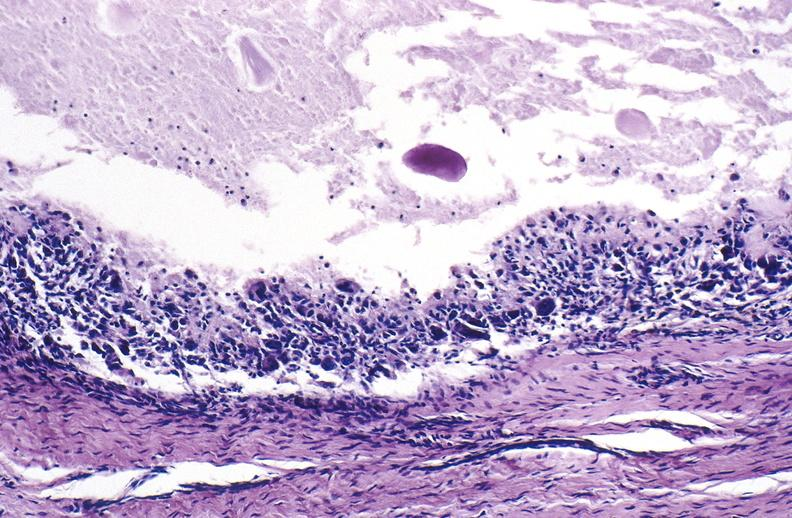s joints present?
Answer the question using a single word or phrase. Yes 